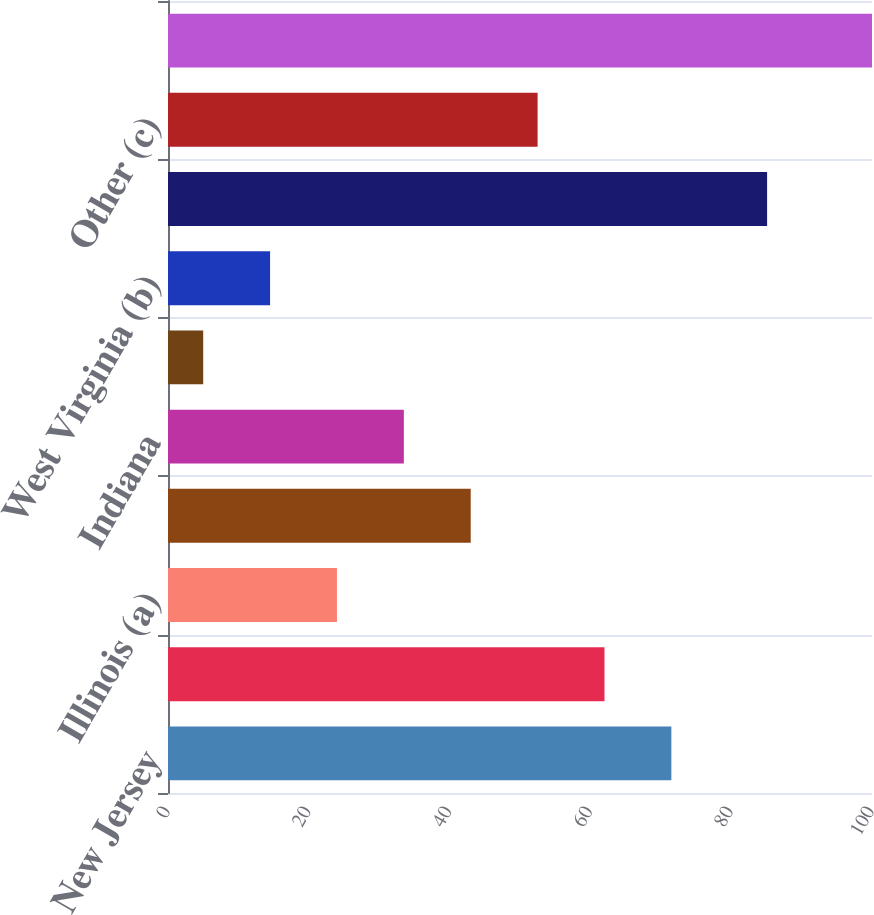Convert chart to OTSL. <chart><loc_0><loc_0><loc_500><loc_500><bar_chart><fcel>New Jersey<fcel>Pennsylvania<fcel>Illinois (a)<fcel>Missouri<fcel>Indiana<fcel>California<fcel>West Virginia (b)<fcel>Subtotal (Top Seven States)<fcel>Other (c)<fcel>Total Regulated Businesses<nl><fcel>71.5<fcel>62<fcel>24<fcel>43<fcel>33.5<fcel>5<fcel>14.5<fcel>85.1<fcel>52.5<fcel>100<nl></chart> 